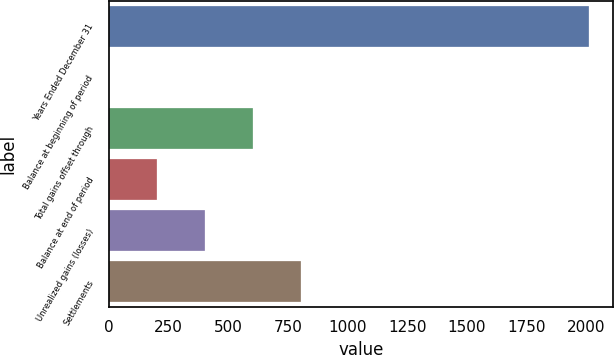Convert chart. <chart><loc_0><loc_0><loc_500><loc_500><bar_chart><fcel>Years Ended December 31<fcel>Balance at beginning of period<fcel>Total gains offset through<fcel>Balance at end of period<fcel>Unrealized gains (losses)<fcel>Settlements<nl><fcel>2012<fcel>2<fcel>605<fcel>203<fcel>404<fcel>806<nl></chart> 